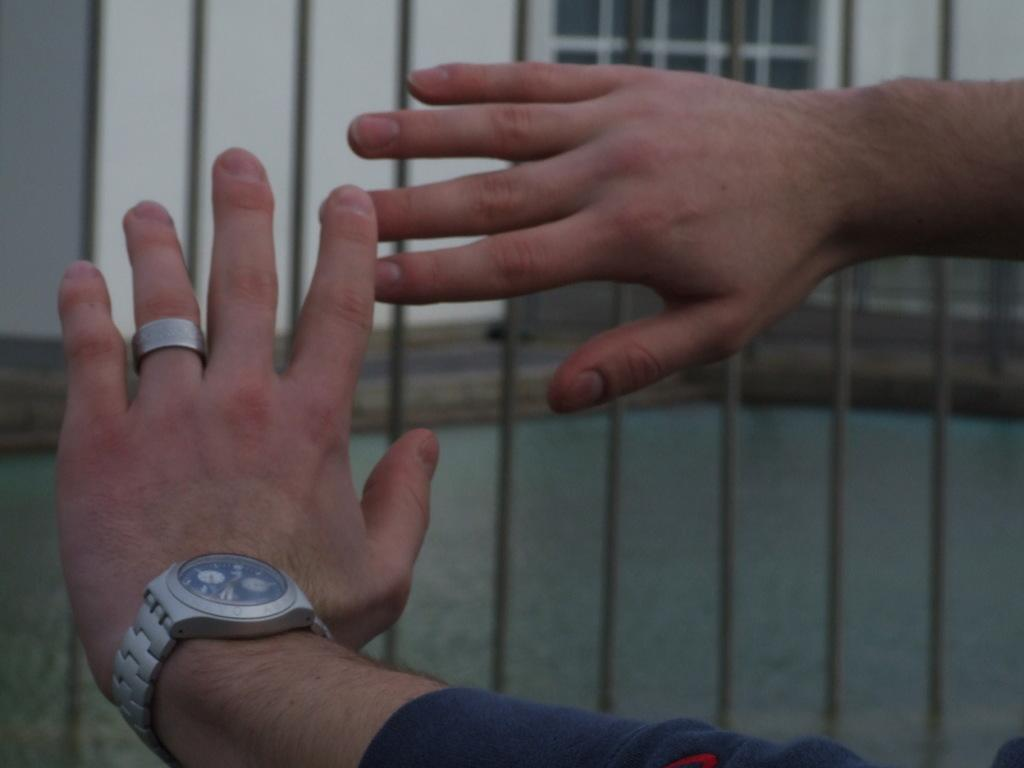What body part is visible in the image? There are hands of a person in the image. What accessory is being worn by the person? There is a watch in the image. What can be seen in the background of the image? There is a fence and a wall in the background of the image. What type of hospital can be seen in the background of the image? There is no hospital present in the image; the background features a fence and a wall. 